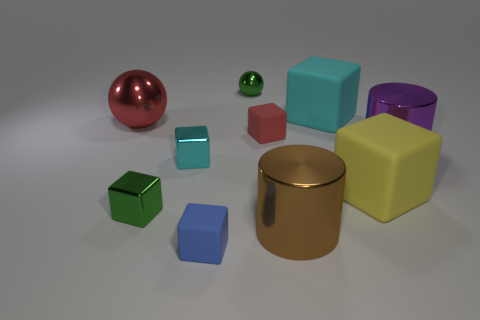What number of shiny blocks are there?
Make the answer very short. 2. How many metal things are right of the small green shiny cube and behind the big yellow block?
Offer a very short reply. 3. What is the big brown cylinder made of?
Offer a very short reply. Metal. Are any big yellow cubes visible?
Ensure brevity in your answer.  Yes. There is a sphere in front of the green metallic sphere; what color is it?
Provide a short and direct response. Red. What number of tiny cyan things are behind the small object that is on the right side of the green thing behind the red sphere?
Ensure brevity in your answer.  0. What is the material of the object that is both in front of the purple thing and to the right of the brown thing?
Make the answer very short. Rubber. Are the yellow block and the small thing right of the green metallic ball made of the same material?
Ensure brevity in your answer.  Yes. Are there more matte cubes behind the small cyan cube than red cubes in front of the large brown metal object?
Provide a succinct answer. Yes. What is the shape of the large red object?
Offer a very short reply. Sphere. 